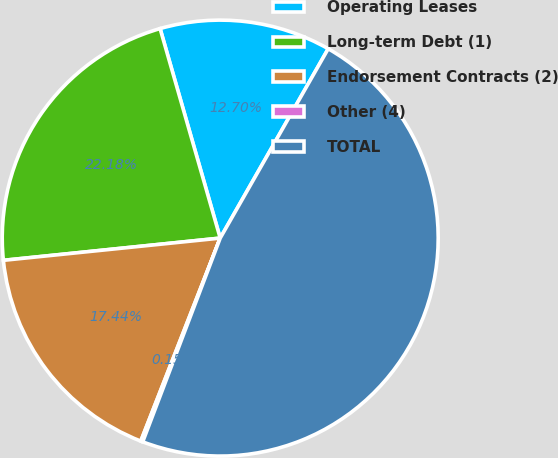<chart> <loc_0><loc_0><loc_500><loc_500><pie_chart><fcel>Operating Leases<fcel>Long-term Debt (1)<fcel>Endorsement Contracts (2)<fcel>Other (4)<fcel>TOTAL<nl><fcel>12.7%<fcel>22.18%<fcel>17.44%<fcel>0.15%<fcel>47.54%<nl></chart> 